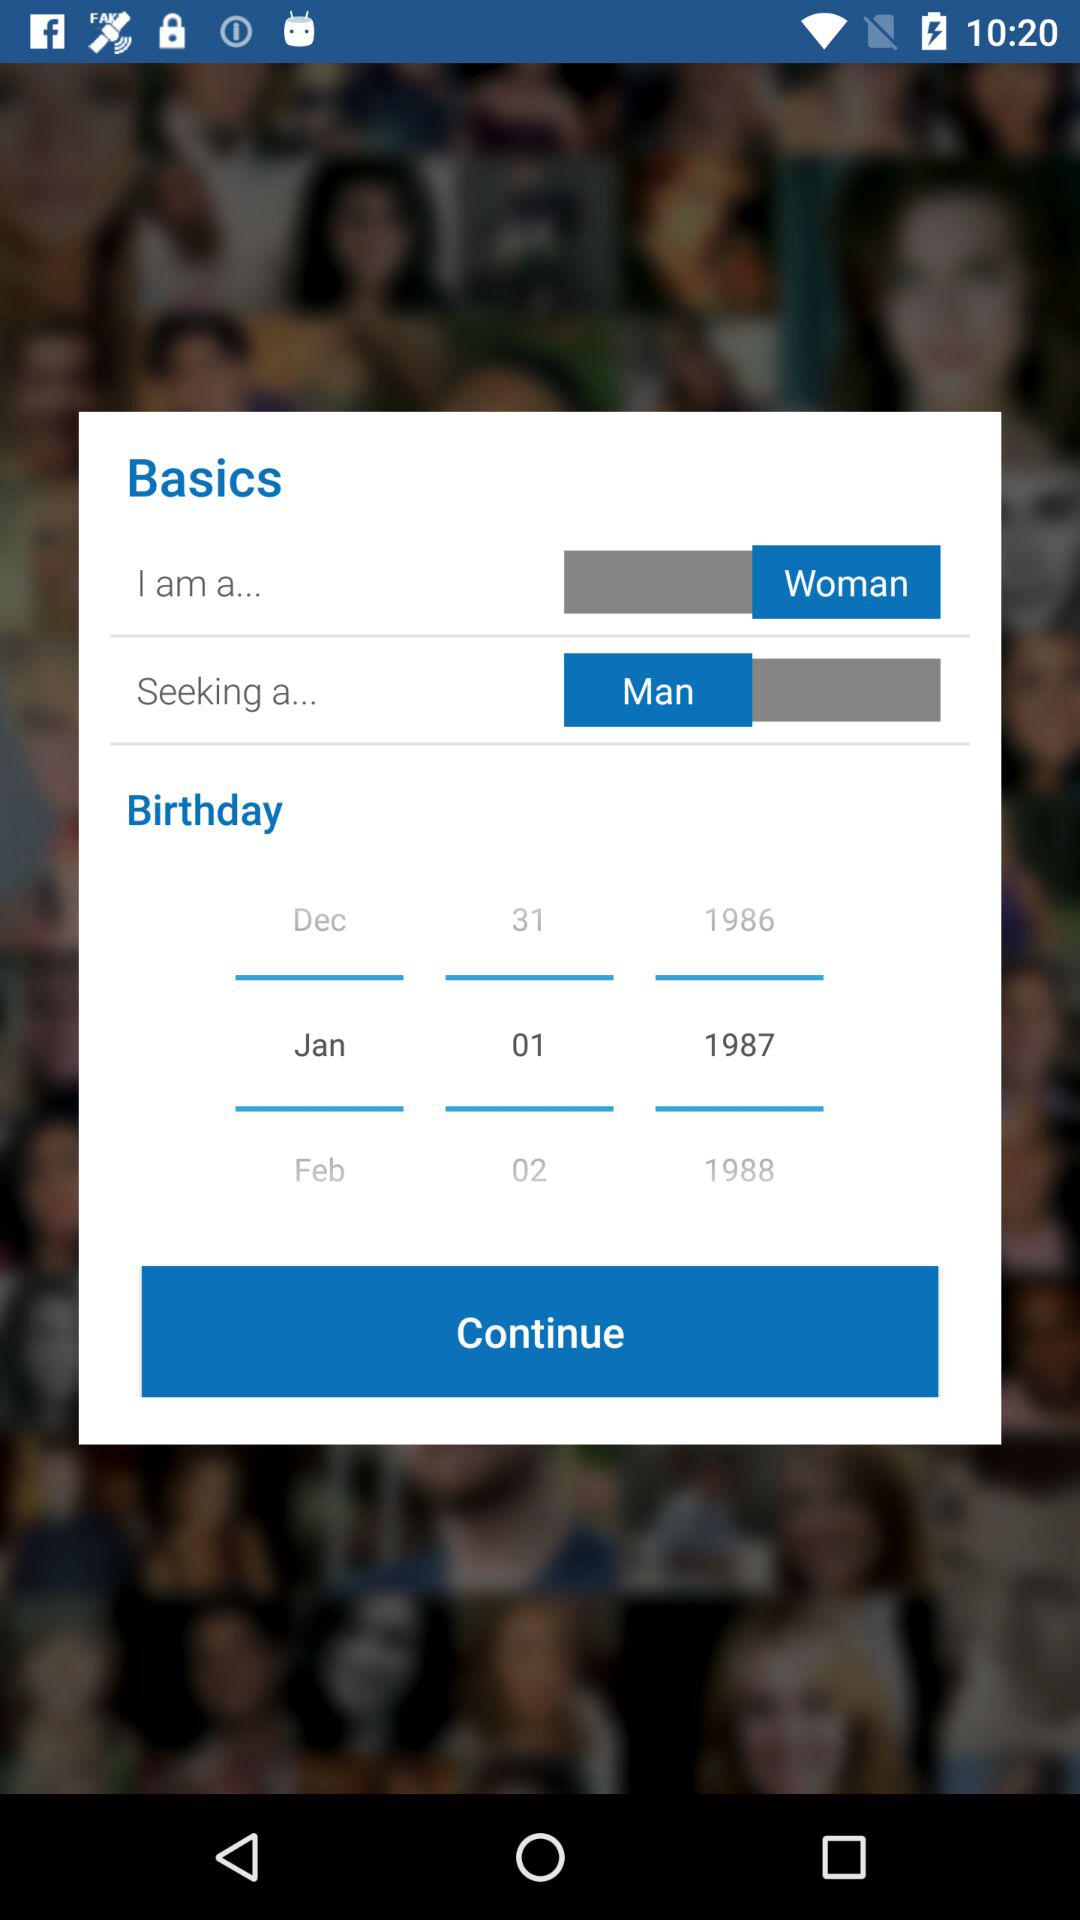Which option is selected for "I am a..." in "Basics"? The selected option is "Woman". 